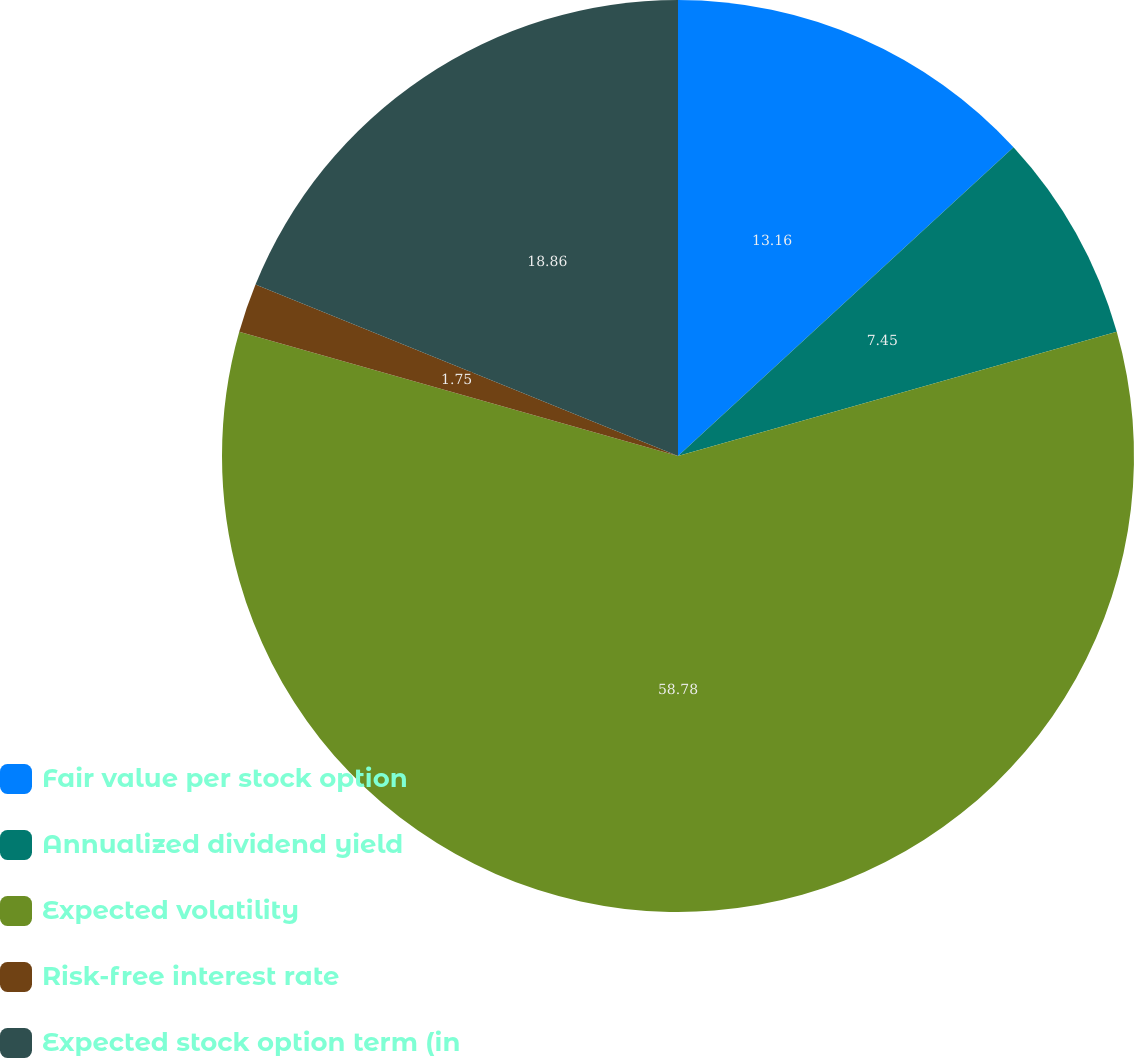Convert chart. <chart><loc_0><loc_0><loc_500><loc_500><pie_chart><fcel>Fair value per stock option<fcel>Annualized dividend yield<fcel>Expected volatility<fcel>Risk-free interest rate<fcel>Expected stock option term (in<nl><fcel>13.16%<fcel>7.45%<fcel>58.78%<fcel>1.75%<fcel>18.86%<nl></chart> 